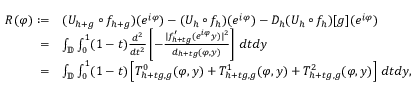Convert formula to latex. <formula><loc_0><loc_0><loc_500><loc_500>\begin{array} { r l } { R ( \varphi ) \colon = } & { ( U _ { h + g } \circ f _ { h + g } ) ( e ^ { i \varphi } ) - ( U _ { h } \circ f _ { h } ) ( e ^ { i \varphi } ) - D _ { h } ( U _ { h } \circ f _ { h } ) [ g ] ( e ^ { i \varphi } ) } \\ { = } & { \int _ { \mathbb { D } } \int _ { 0 } ^ { 1 } ( 1 - t ) \frac { d ^ { 2 } } { d t ^ { 2 } } \left [ - \frac { | f _ { h + t g } ^ { \prime } ( e ^ { i \varphi } y ) | ^ { 2 } } { d _ { h + t g } ( \varphi , y ) } \right ] \, d t d y } \\ { = } & { \int _ { \mathbb { D } } \int _ { 0 } ^ { 1 } ( 1 - t ) \left [ T _ { h + t g , g } ^ { 0 } ( \varphi , y ) + T _ { h + t g , g } ^ { 1 } ( \varphi , y ) + T _ { h + t g , g } ^ { 2 } ( \varphi , y ) \right ] \, d t d y , } \end{array}</formula> 